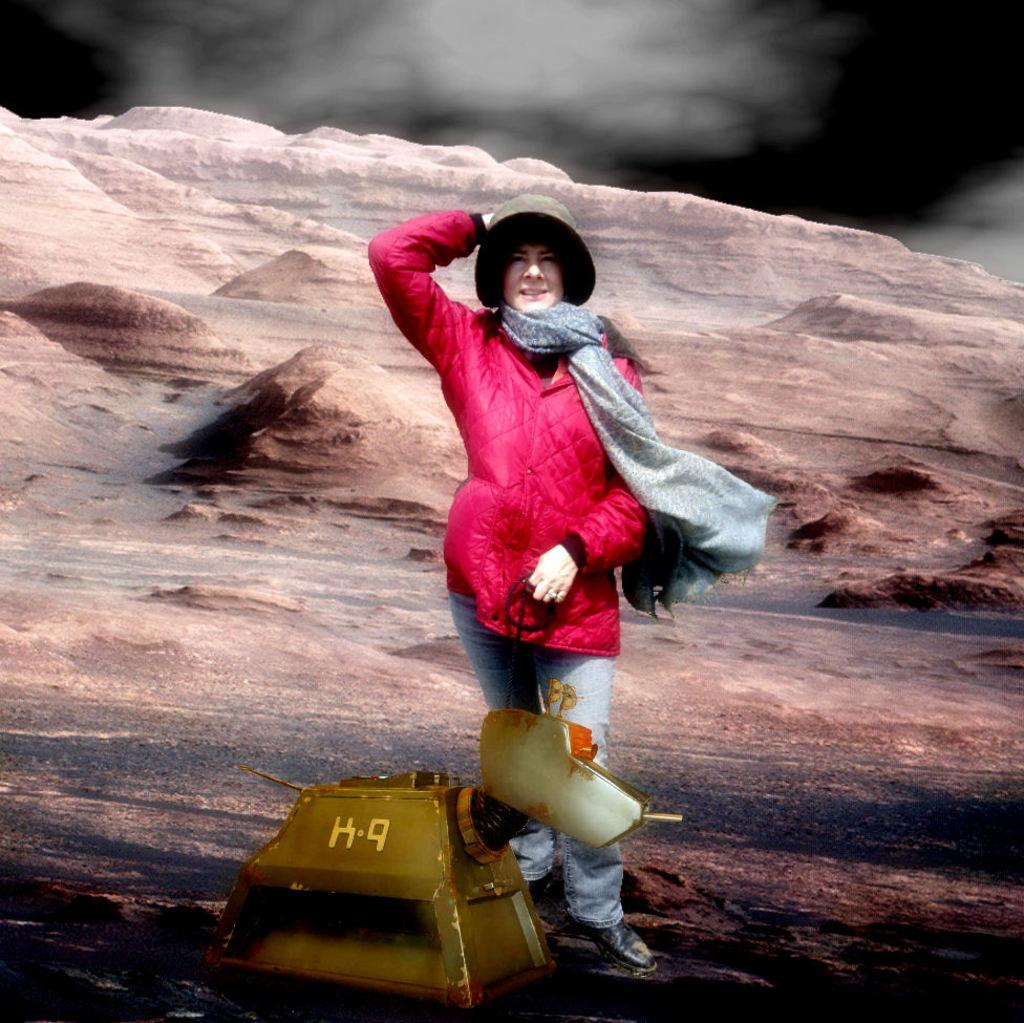Who is present in the image? There is a woman in the image. What is the woman wearing? The woman is wearing a jacket, a scarf, and a cap. What is the woman doing in the image? The woman is standing and smiling. What else can be seen in the image? There is a machine and rocks in the image. How would you describe the background of the image? The background of the image is blurry. What type of scissors can be seen cutting the woman's hair in the image? There are no scissors or hair cutting activity depicted in the image. How often does the woman wash the rocks in the image? There is no indication of the woman washing rocks or any washing activity in the image. 